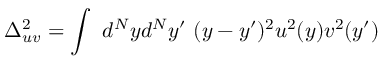<formula> <loc_0><loc_0><loc_500><loc_500>\Delta _ { u v } ^ { 2 } = \int d ^ { N } y d ^ { N } y ^ { \prime } ( y - y ^ { \prime } ) ^ { 2 } u ^ { 2 } ( y ) v ^ { 2 } ( y ^ { \prime } )</formula> 